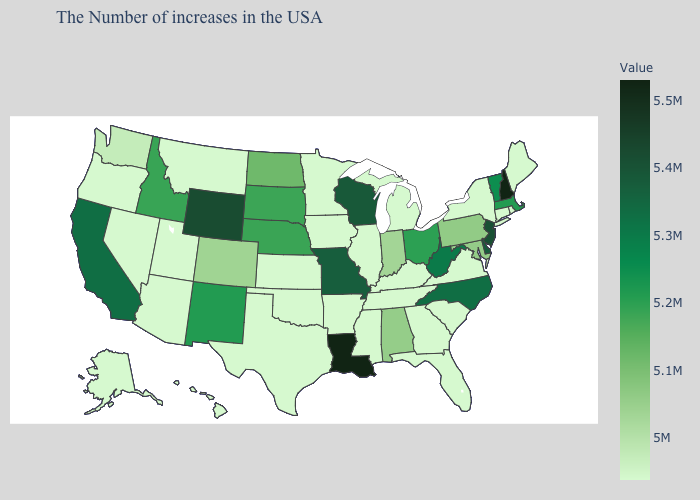Among the states that border West Virginia , which have the lowest value?
Keep it brief. Virginia, Kentucky. Does Minnesota have the highest value in the USA?
Give a very brief answer. No. Does Louisiana have the highest value in the South?
Be succinct. Yes. Does Idaho have a lower value than North Carolina?
Write a very short answer. Yes. Among the states that border Vermont , does New York have the highest value?
Write a very short answer. No. Among the states that border New Jersey , which have the lowest value?
Write a very short answer. New York. 